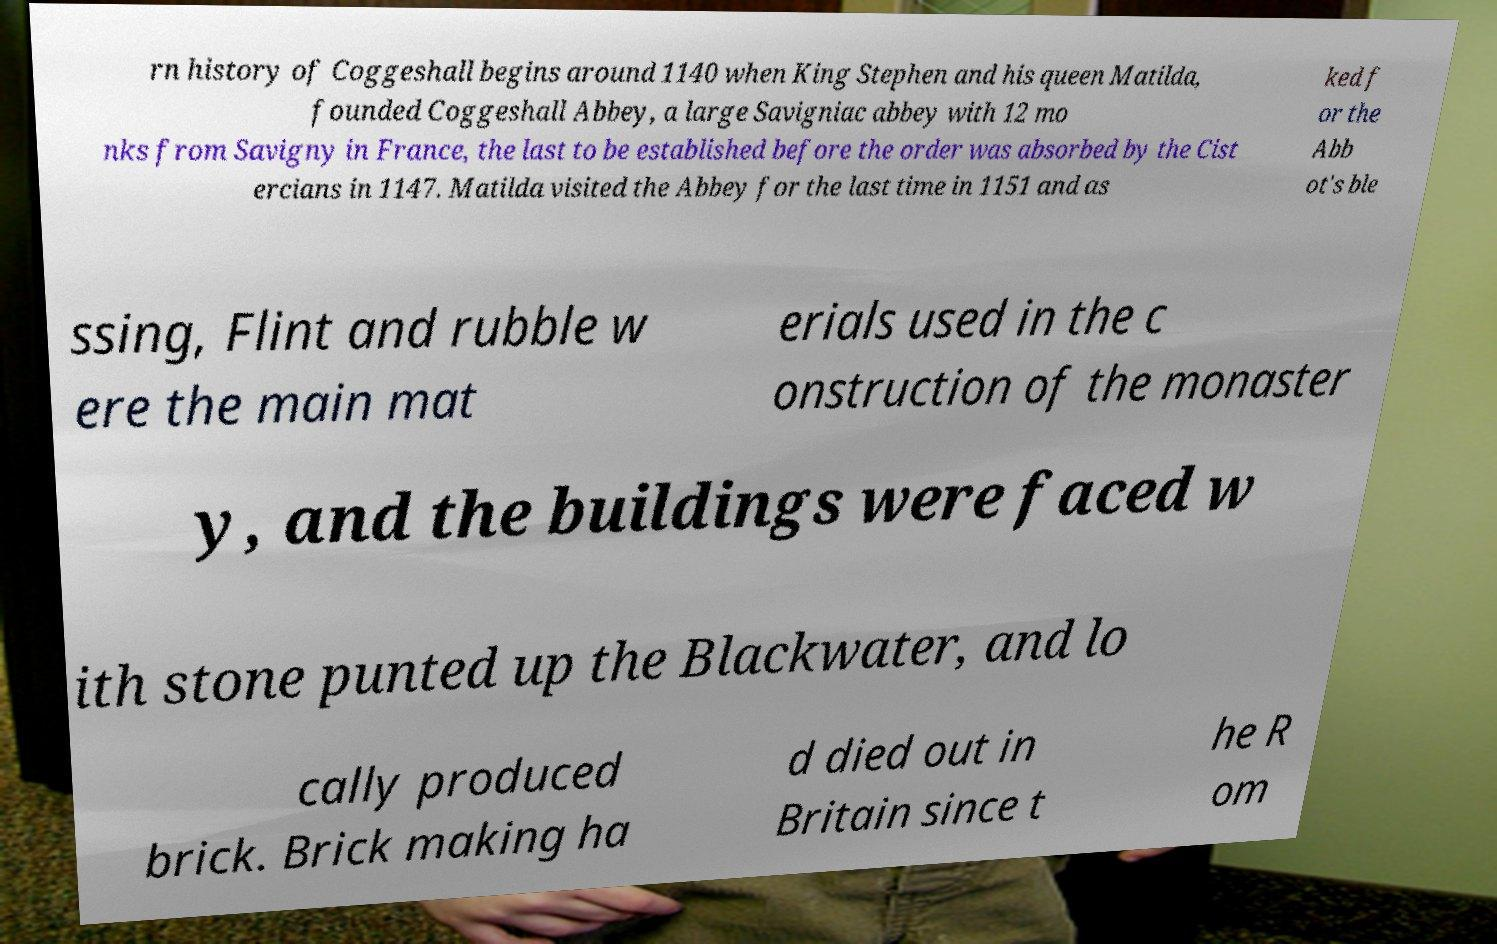What messages or text are displayed in this image? I need them in a readable, typed format. rn history of Coggeshall begins around 1140 when King Stephen and his queen Matilda, founded Coggeshall Abbey, a large Savigniac abbey with 12 mo nks from Savigny in France, the last to be established before the order was absorbed by the Cist ercians in 1147. Matilda visited the Abbey for the last time in 1151 and as ked f or the Abb ot's ble ssing, Flint and rubble w ere the main mat erials used in the c onstruction of the monaster y, and the buildings were faced w ith stone punted up the Blackwater, and lo cally produced brick. Brick making ha d died out in Britain since t he R om 